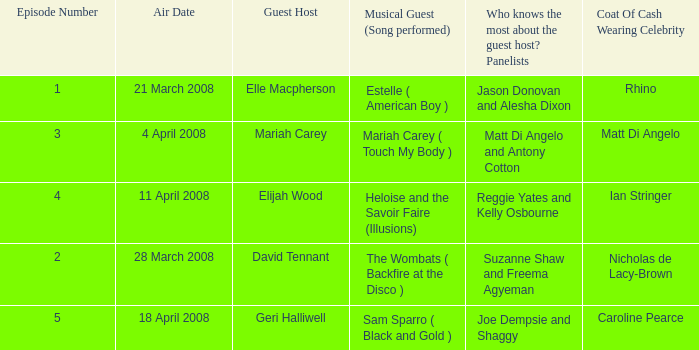Name the number of panelists for oat of cash wearing celebrity being matt di angelo 1.0. 